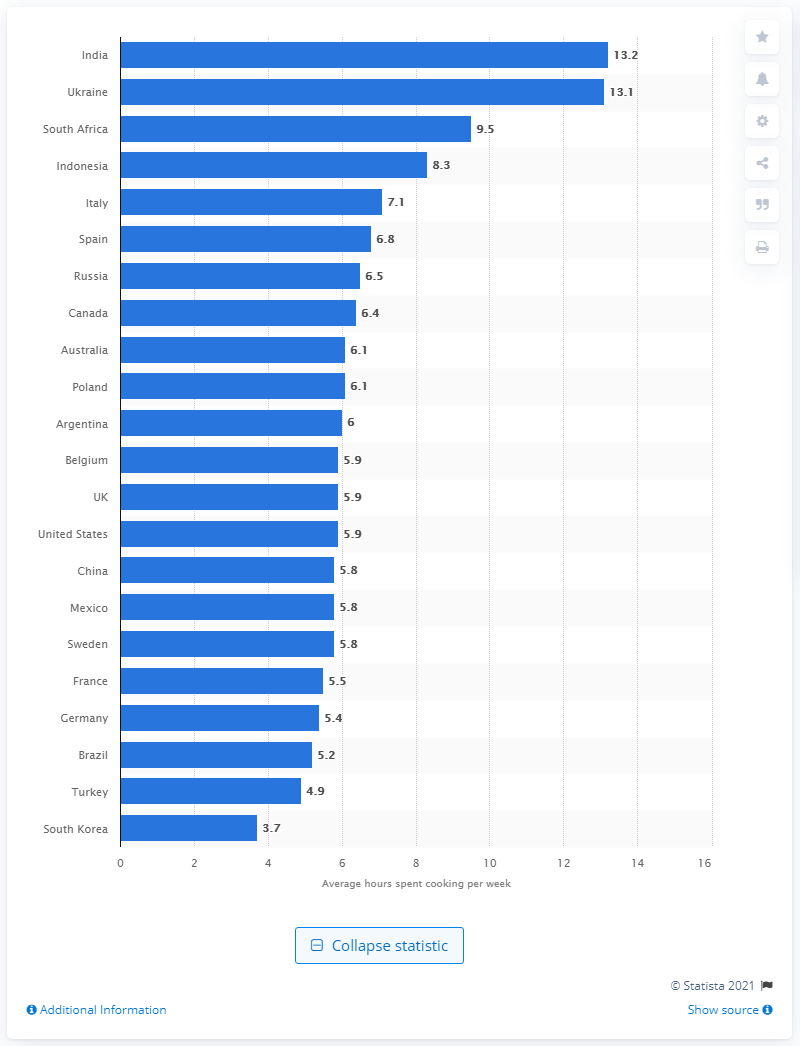Identify some key points in this picture. The average amount of time spent cooking per week in India is 13.2 hours. 